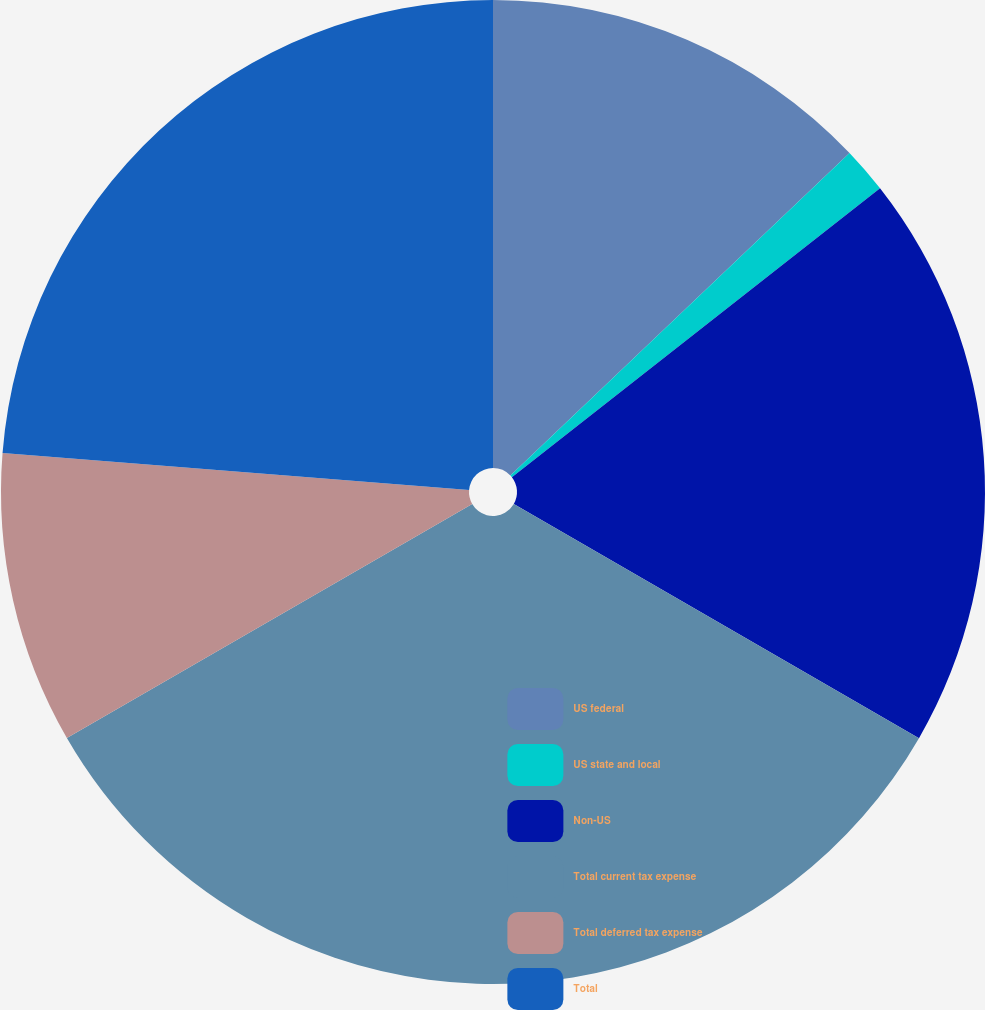<chart> <loc_0><loc_0><loc_500><loc_500><pie_chart><fcel>US federal<fcel>US state and local<fcel>Non-US<fcel>Total current tax expense<fcel>Total deferred tax expense<fcel>Total<nl><fcel>12.9%<fcel>1.51%<fcel>18.93%<fcel>33.33%<fcel>9.59%<fcel>23.74%<nl></chart> 